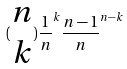Convert formula to latex. <formula><loc_0><loc_0><loc_500><loc_500>( \begin{matrix} n \\ k \end{matrix} ) \frac { 1 } { n } ^ { k } \frac { n - 1 } { n } ^ { n - k }</formula> 